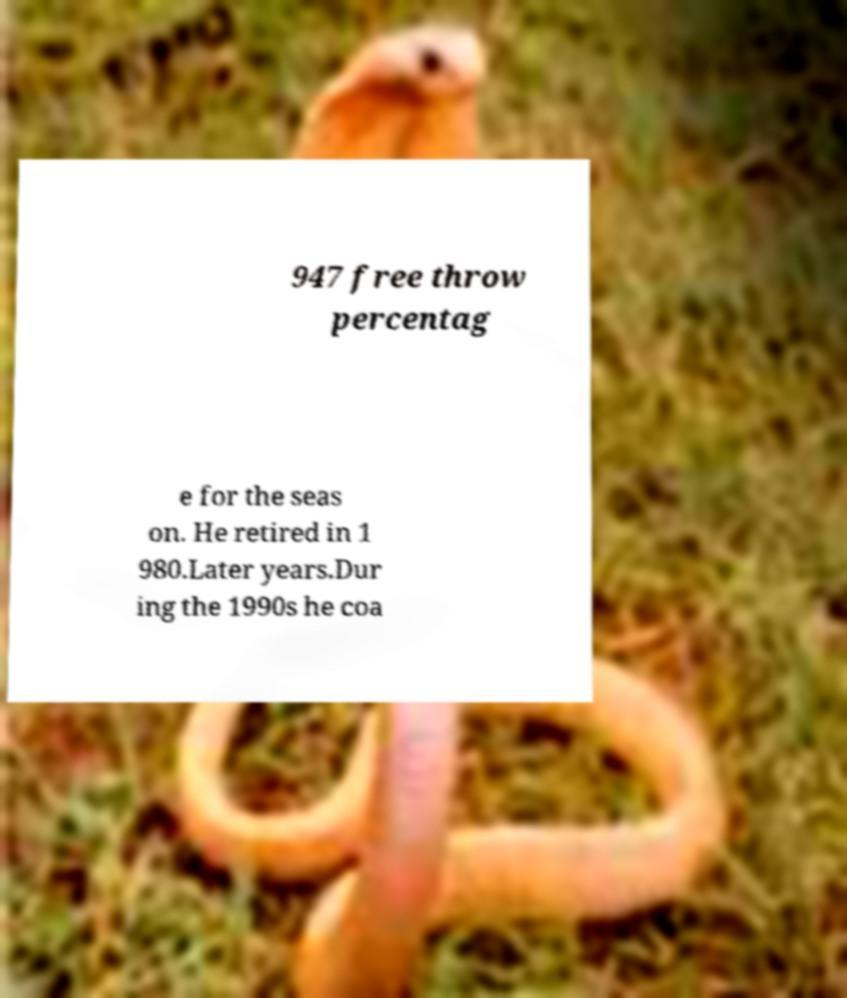Could you assist in decoding the text presented in this image and type it out clearly? 947 free throw percentag e for the seas on. He retired in 1 980.Later years.Dur ing the 1990s he coa 